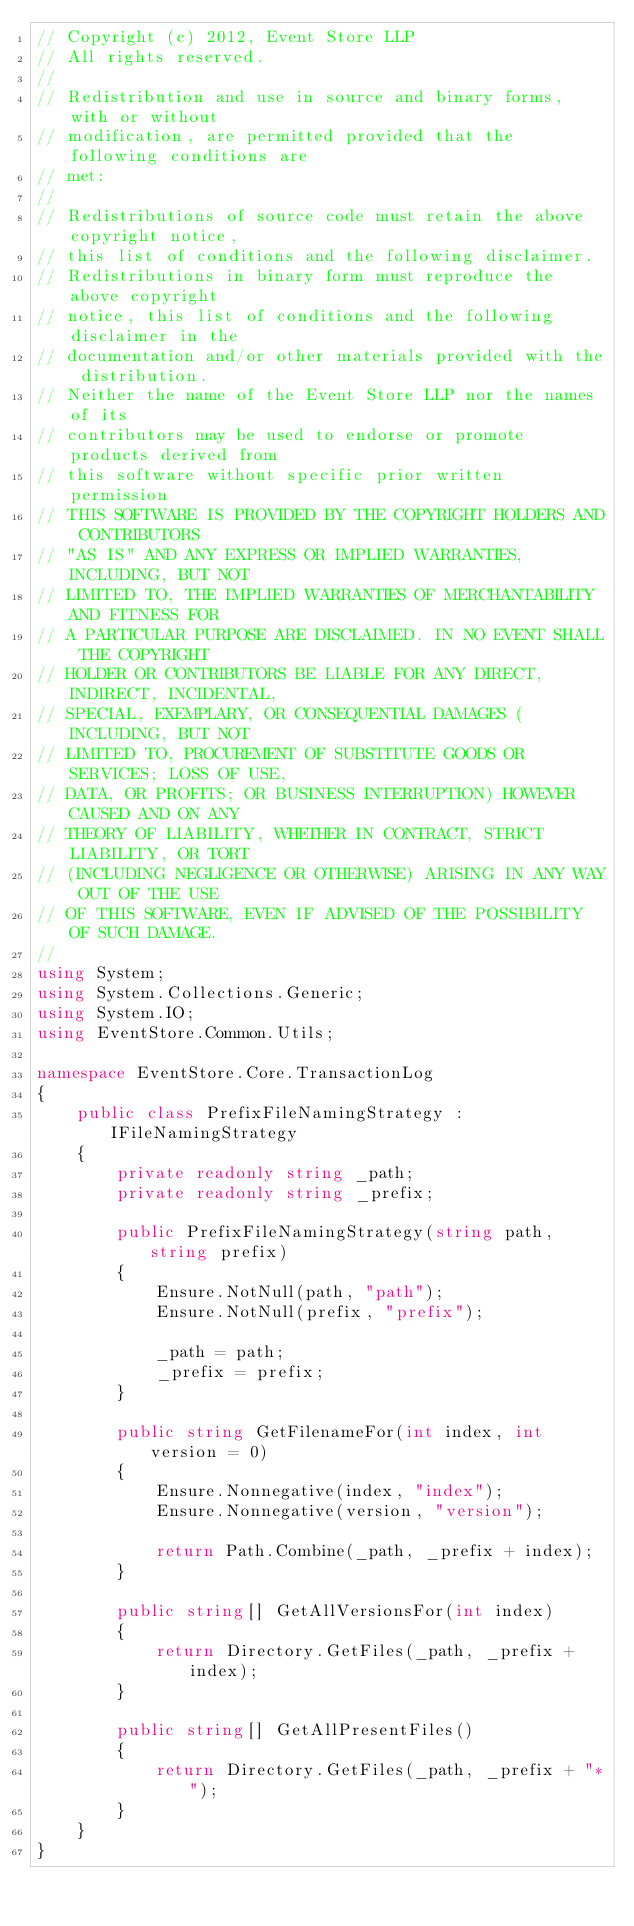<code> <loc_0><loc_0><loc_500><loc_500><_C#_>// Copyright (c) 2012, Event Store LLP
// All rights reserved.
// 
// Redistribution and use in source and binary forms, with or without
// modification, are permitted provided that the following conditions are
// met:
// 
// Redistributions of source code must retain the above copyright notice,
// this list of conditions and the following disclaimer.
// Redistributions in binary form must reproduce the above copyright
// notice, this list of conditions and the following disclaimer in the
// documentation and/or other materials provided with the distribution.
// Neither the name of the Event Store LLP nor the names of its
// contributors may be used to endorse or promote products derived from
// this software without specific prior written permission
// THIS SOFTWARE IS PROVIDED BY THE COPYRIGHT HOLDERS AND CONTRIBUTORS
// "AS IS" AND ANY EXPRESS OR IMPLIED WARRANTIES, INCLUDING, BUT NOT
// LIMITED TO, THE IMPLIED WARRANTIES OF MERCHANTABILITY AND FITNESS FOR
// A PARTICULAR PURPOSE ARE DISCLAIMED. IN NO EVENT SHALL THE COPYRIGHT
// HOLDER OR CONTRIBUTORS BE LIABLE FOR ANY DIRECT, INDIRECT, INCIDENTAL,
// SPECIAL, EXEMPLARY, OR CONSEQUENTIAL DAMAGES (INCLUDING, BUT NOT
// LIMITED TO, PROCUREMENT OF SUBSTITUTE GOODS OR SERVICES; LOSS OF USE,
// DATA, OR PROFITS; OR BUSINESS INTERRUPTION) HOWEVER CAUSED AND ON ANY
// THEORY OF LIABILITY, WHETHER IN CONTRACT, STRICT LIABILITY, OR TORT
// (INCLUDING NEGLIGENCE OR OTHERWISE) ARISING IN ANY WAY OUT OF THE USE
// OF THIS SOFTWARE, EVEN IF ADVISED OF THE POSSIBILITY OF SUCH DAMAGE.
// 
using System;
using System.Collections.Generic;
using System.IO;
using EventStore.Common.Utils;

namespace EventStore.Core.TransactionLog
{
    public class PrefixFileNamingStrategy : IFileNamingStrategy 
    {
        private readonly string _path;
        private readonly string _prefix;

        public PrefixFileNamingStrategy(string path, string prefix)
        {
            Ensure.NotNull(path, "path");
            Ensure.NotNull(prefix, "prefix");

            _path = path;
            _prefix = prefix;
        }

        public string GetFilenameFor(int index, int version = 0)
        {
            Ensure.Nonnegative(index, "index");
            Ensure.Nonnegative(version, "version");

            return Path.Combine(_path, _prefix + index);
        }

        public string[] GetAllVersionsFor(int index)
        {
            return Directory.GetFiles(_path, _prefix + index);
        }

        public string[] GetAllPresentFiles()
        {
            return Directory.GetFiles(_path, _prefix + "*");
        }
    }
}</code> 